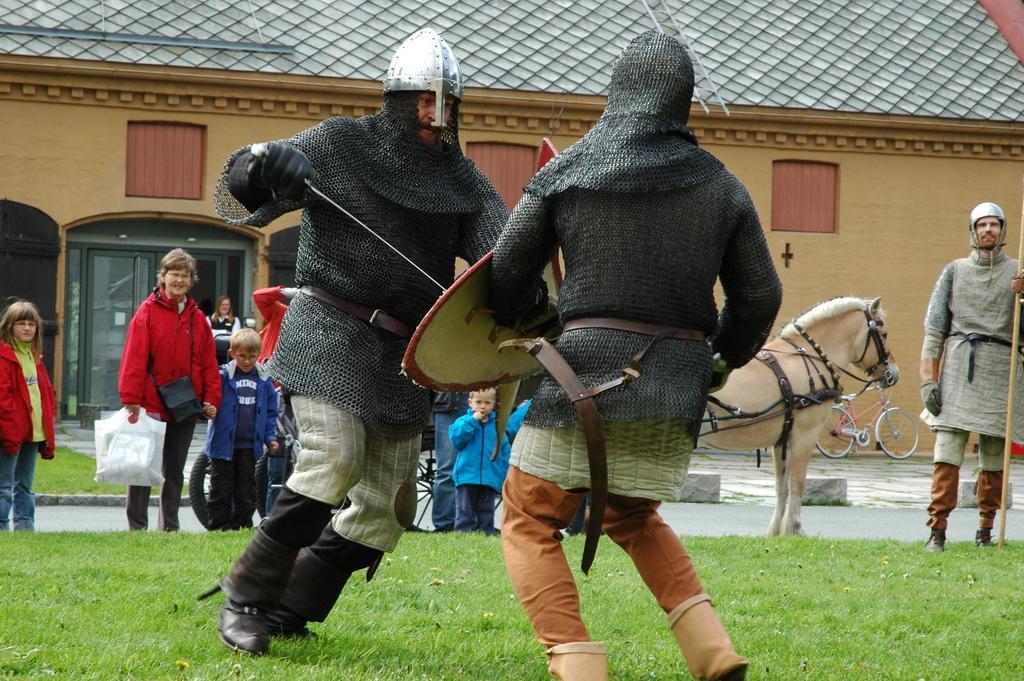Describe this image in one or two sentences. In this image I can see two people are wearing different costumes and holding something. Back I can see a house,bicycle,doors,windows,cream colored horse,few people are standing and holding bags. 